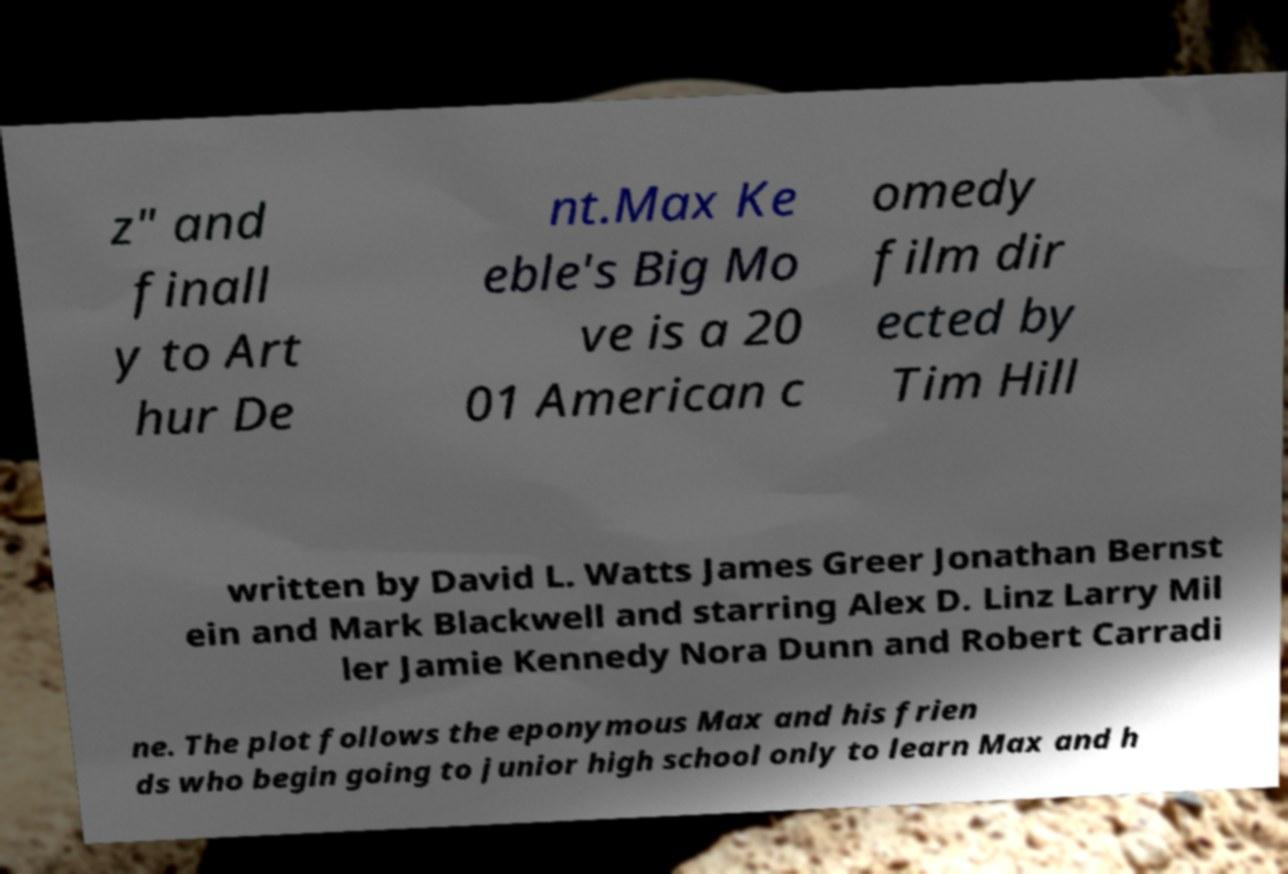For documentation purposes, I need the text within this image transcribed. Could you provide that? z" and finall y to Art hur De nt.Max Ke eble's Big Mo ve is a 20 01 American c omedy film dir ected by Tim Hill written by David L. Watts James Greer Jonathan Bernst ein and Mark Blackwell and starring Alex D. Linz Larry Mil ler Jamie Kennedy Nora Dunn and Robert Carradi ne. The plot follows the eponymous Max and his frien ds who begin going to junior high school only to learn Max and h 